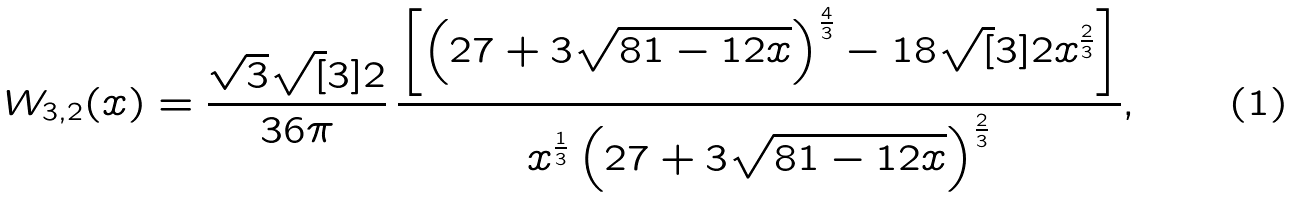Convert formula to latex. <formula><loc_0><loc_0><loc_500><loc_500>\, W _ { 3 , 2 } ( x ) = \frac { \sqrt { 3 } \sqrt { [ } 3 ] { 2 } } { 3 6 \pi } \, \frac { \left [ \left ( 2 7 + 3 \sqrt { 8 1 - 1 2 x } \right ) ^ { \frac { 4 } { 3 } } - 1 8 \sqrt { [ } 3 ] { 2 } x ^ { \frac { 2 } { 3 } } \right ] } { x ^ { \frac { 1 } { 3 } } \left ( 2 7 + 3 \sqrt { 8 1 - 1 2 x } \right ) ^ { \frac { 2 } { 3 } } } ,</formula> 